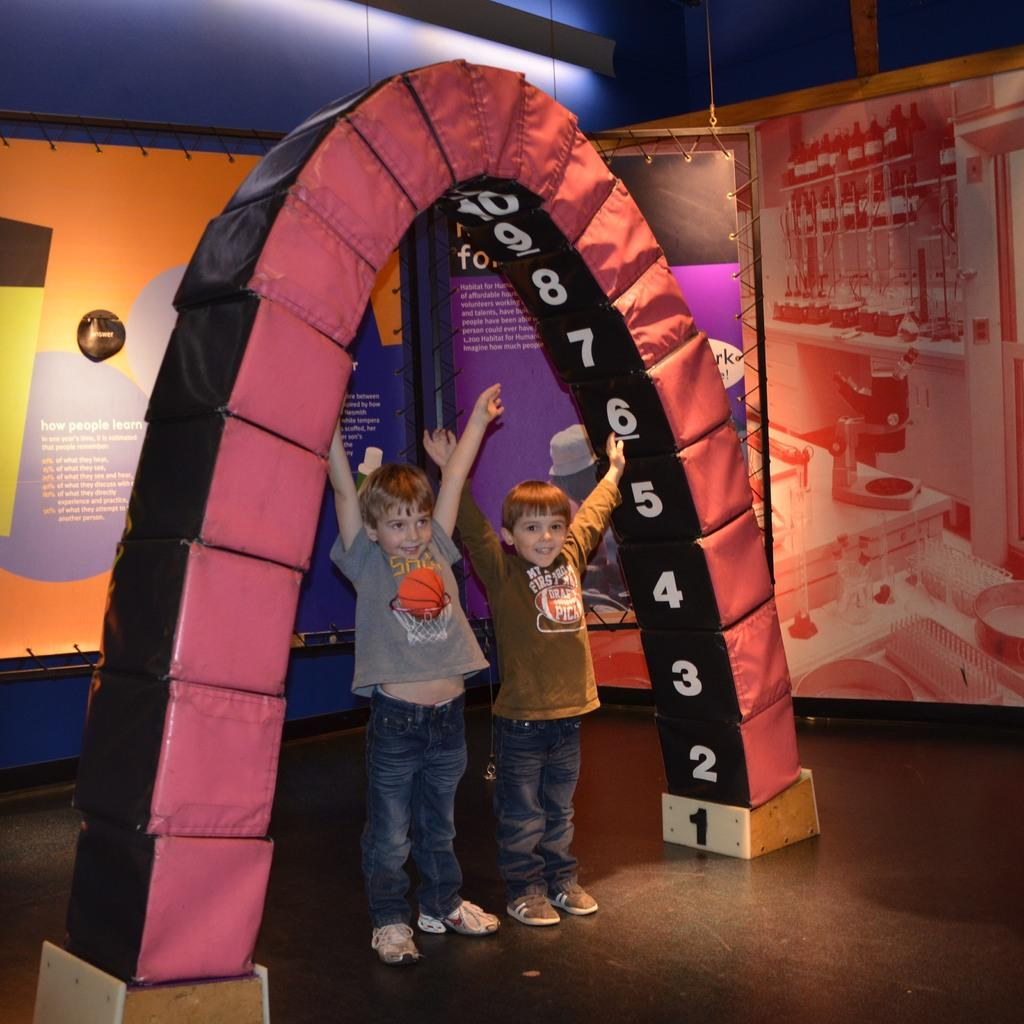Who is present in the image? There are kids in the image. What type of activity is depicted in the image? There is a fun ride in the image. Can you describe the fun ride? The fun ride appears to be an archetype. What else can be seen in the image? There are boards in the image. What is the base of the image? There is a floor at the bottom of the image. What type of throat medicine is visible in the image? There is no throat medicine present in the image. What type of trail can be seen in the image? There is no trail visible in the image. 